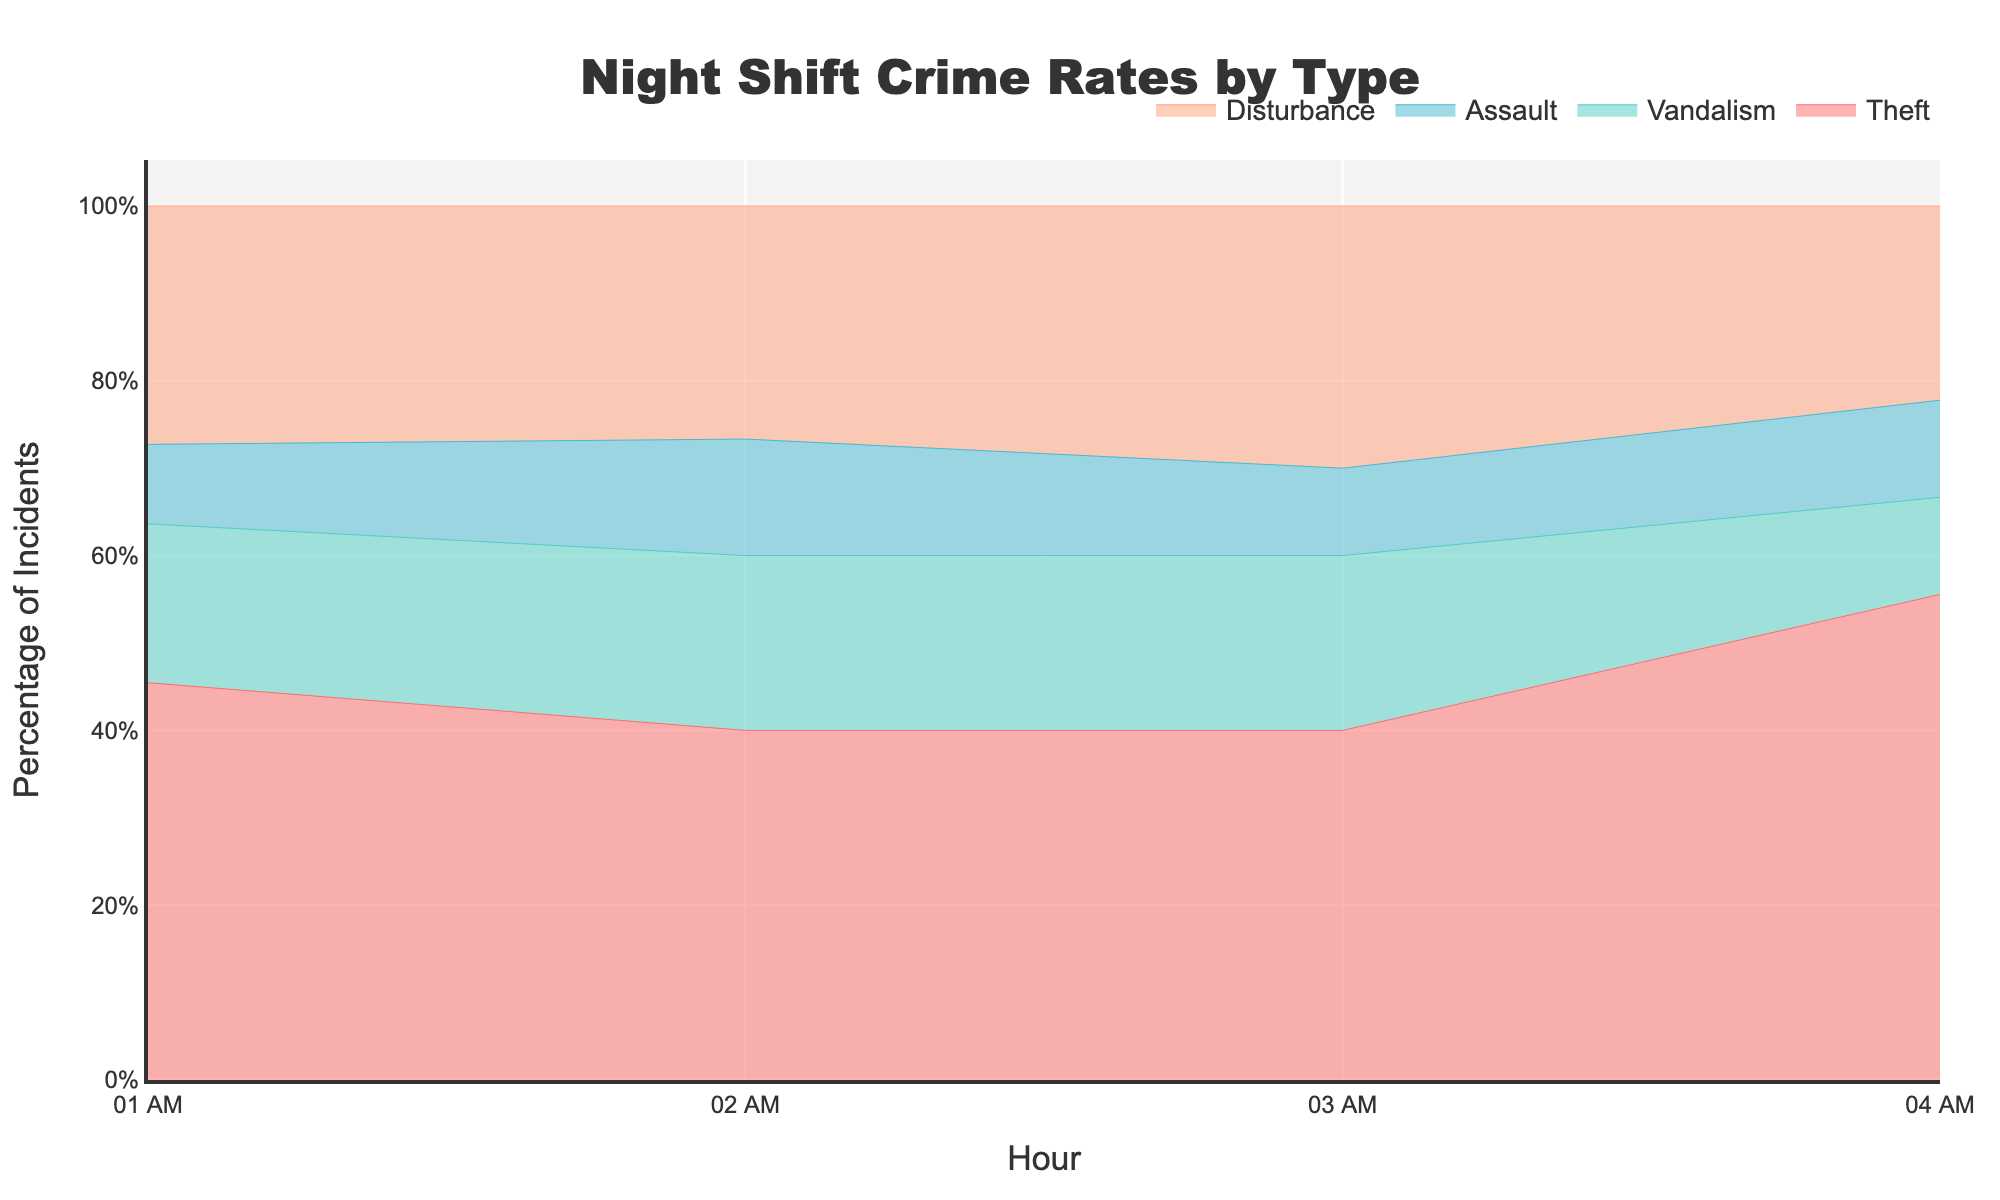What is the title of the figure? The title is located at the top of the figure. It reads "Night Shift Crime Rates by Type."
Answer: Night Shift Crime Rates by Type Which crime type has the most incidents at 2 AM? By examining the stream graph at the 2 AM mark, we see which colored line is highest. The red section (Theft) is the most prominent.
Answer: Theft During which hour is the resolution time of Disturbance incidents shortest? Hover over the stream representing Disturbance and look at the hover text for each hour. At 2 AM, the text shows "Resolution Time: 15 min," which is the shortest compared to other hours.
Answer: 2 AM How do the percentage of incidents at 1 AM compare between Theft and Vandalism? At 1 AM, observe the heights of the stream sections for Theft (red) and Vandalism (teal). The Theft section is taller than Vandalism.
Answer: Theft is higher than Vandalism Calculate the average resolution time for Assault incidents based on the figure. Hover over each hour for the Assault section and note the resolution times: 60, 70, 75, and 80 minutes. Sum them up (60 + 70 + 75 + 80 = 285) and divide by the number of times (4).
Answer: 71.25 minutes Which crime type shows a decline in incidents from 1 AM to 4 AM? Look for streams that decrease in height from left (1 AM) to right (4 AM). The purple section (Assault) decreases over time.
Answer: Assault At what hour do Theft incidents peak? Observe the red stream for Theft and find the hour where it is at its highest point. The peak is at 2 AM.
Answer: 2 AM What is the trend of the resolution time for Vandalism incidents from 1 AM to 4 AM? Hover over the teal section for Vandalism and read the resolution times for each hour: 40, 45, 50, and 55 minutes. Notice that the resolution time increases over the hours.
Answer: Increasing Compare the percentage of incidents for Theft and Disturbance at 3 AM. Check the heights of the red (Theft) and blue (Disturbance) streams at 3 AM. The red section (Theft) is slightly higher than the blue section (Disturbance).
Answer: Theft is higher than Disturbance What is the pattern of disturbance incidents throughout the night? Look at the blue section representing Disturbance. It fluctuates but generally, it decreases from 1 AM to 4 AM.
Answer: Fluctuates; generally decreases 